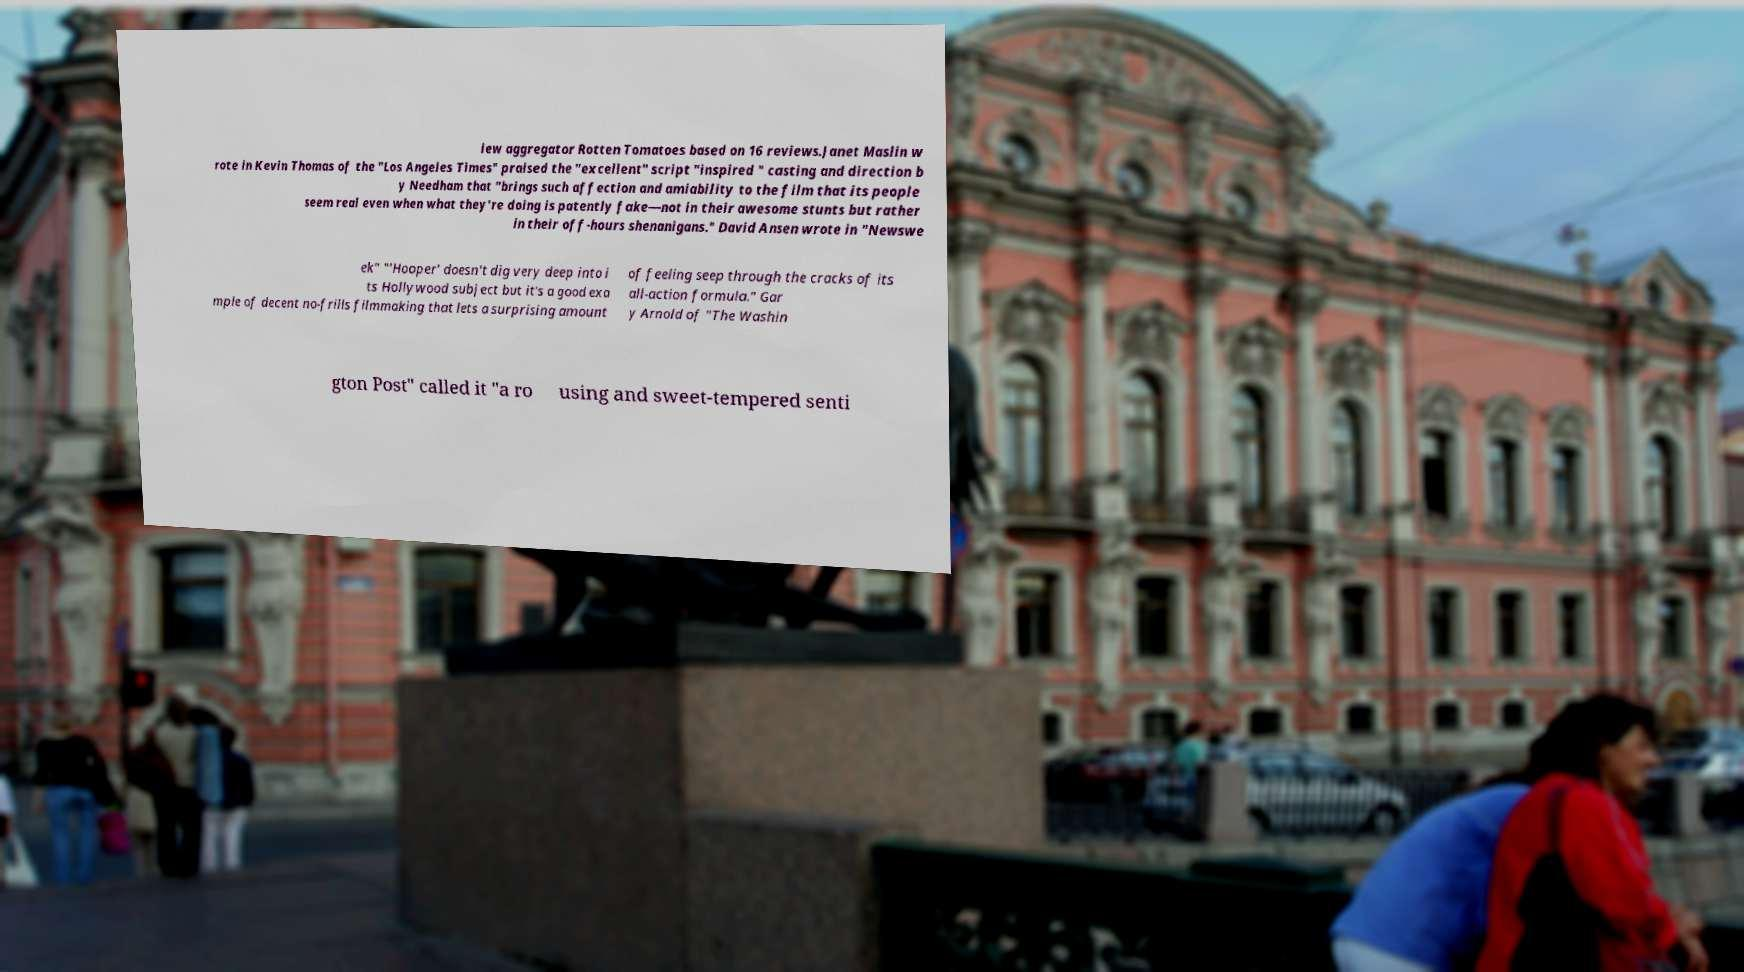Please read and relay the text visible in this image. What does it say? iew aggregator Rotten Tomatoes based on 16 reviews.Janet Maslin w rote in Kevin Thomas of the "Los Angeles Times" praised the "excellent" script "inspired " casting and direction b y Needham that "brings such affection and amiability to the film that its people seem real even when what they're doing is patently fake—not in their awesome stunts but rather in their off-hours shenanigans." David Ansen wrote in "Newswe ek" "'Hooper' doesn't dig very deep into i ts Hollywood subject but it's a good exa mple of decent no-frills filmmaking that lets a surprising amount of feeling seep through the cracks of its all-action formula." Gar y Arnold of "The Washin gton Post" called it "a ro using and sweet-tempered senti 